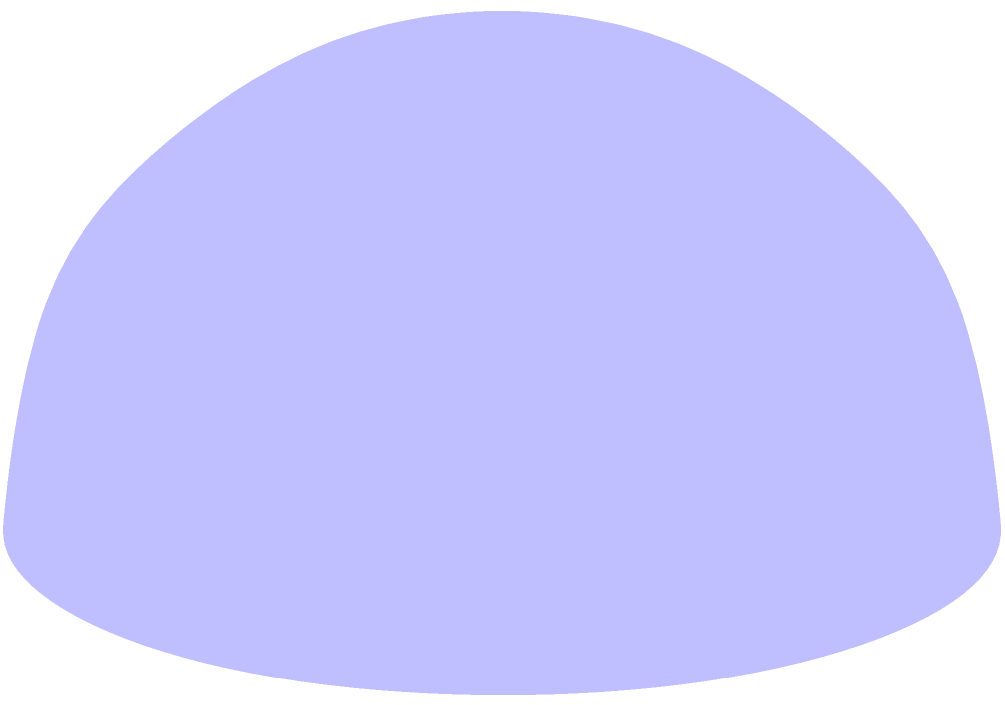You're planning a trip around the world for your family and want to calculate the shortest distance between two cities on Earth. Assuming the Earth is a perfect sphere with a radius of 6,371 km, what is the shortest distance along the surface between two cities located at points A(1,0,0) and B(0,1,0) on the unit sphere? Express your answer in kilometers, rounded to the nearest whole number. To solve this problem, we'll follow these steps:

1) The shortest path between two points on a sphere's surface is along a great circle, which is represented by the red arc in the diagram.

2) To find the length of this arc, we need to calculate the central angle between the two points and then use the arc length formula.

3) The central angle θ can be found using the dot product of the two position vectors:

   $$\cos\theta = \vec{A} \cdot \vec{B} = (1,0,0) \cdot (0,1,0) = 0$$

4) Since $\cos\theta = 0$, we know that $\theta = \frac{\pi}{2}$ radians or 90 degrees.

5) The arc length formula on a sphere is:

   $$s = r\theta$$

   where $r$ is the radius of the sphere and $\theta$ is in radians.

6) Substituting the values:

   $$s = 6371 \times \frac{\pi}{2} \approx 10,007.54 \text{ km}$$

7) Rounding to the nearest whole number:

   $$s \approx 10,008 \text{ km}$$

This distance represents the shortest path your family would need to travel between these two points on the Earth's surface.
Answer: 10,008 km 